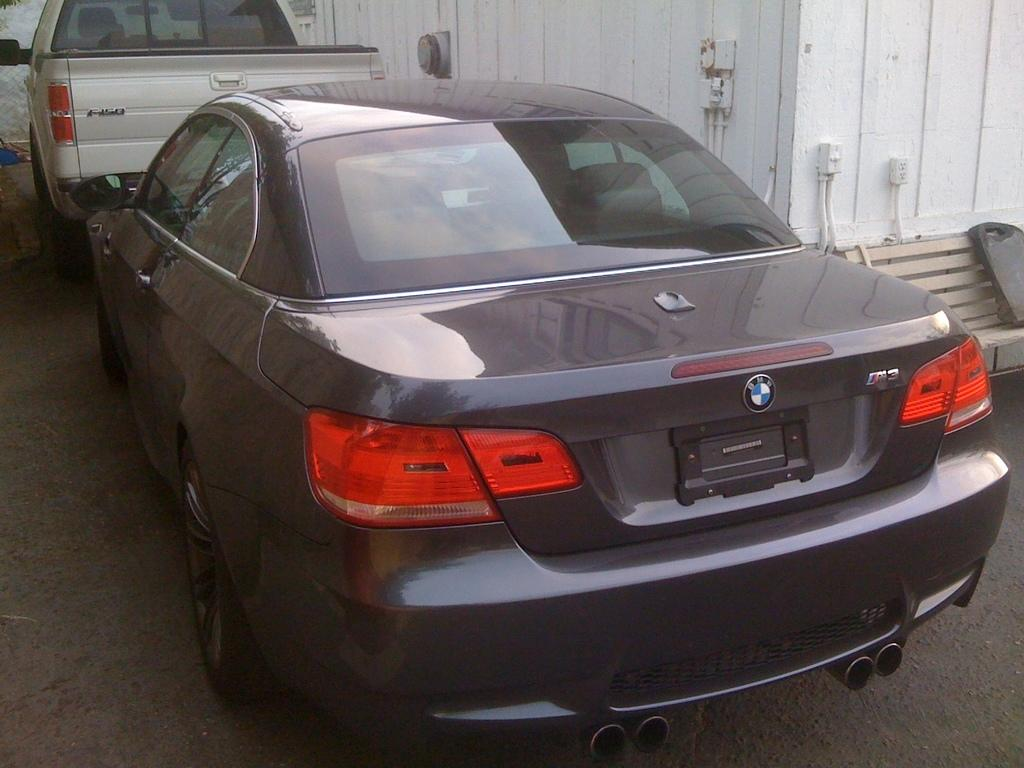What types of vehicles are on the ground in the image? The specific types of vehicles cannot be determined from the provided facts. What kind of objects are on the wall in the image? The specific objects on the wall cannot be determined from the provided facts. Where is the object located on the right side of the image? The object is on a bench on the right side of the image. What color is the representative's tongue in the image? There is no representative or tongue present in the image. 